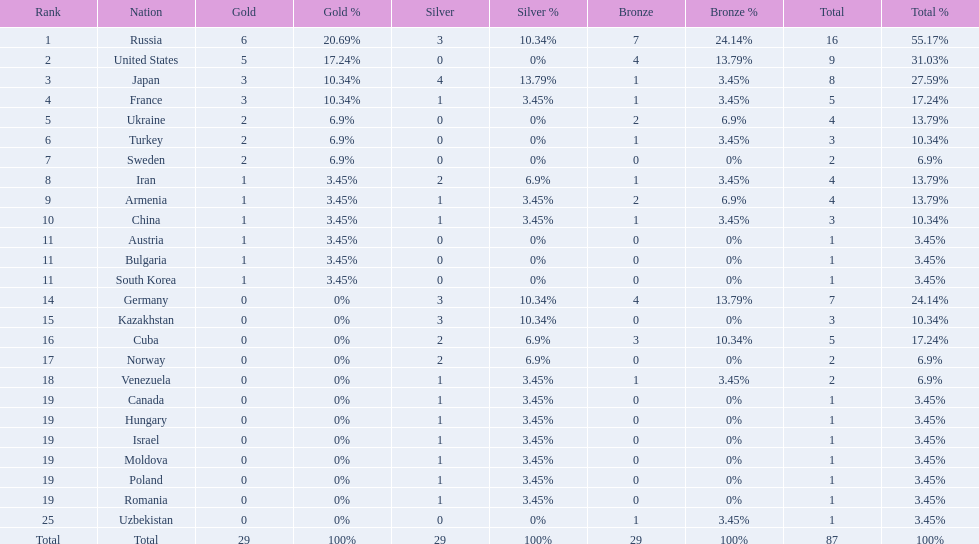Which countries competed in the 1995 world wrestling championships? Russia, United States, Japan, France, Ukraine, Turkey, Sweden, Iran, Armenia, China, Austria, Bulgaria, South Korea, Germany, Kazakhstan, Cuba, Norway, Venezuela, Canada, Hungary, Israel, Moldova, Poland, Romania, Uzbekistan. What country won only one medal? Austria, Bulgaria, South Korea, Canada, Hungary, Israel, Moldova, Poland, Romania, Uzbekistan. Which of these won a bronze medal? Uzbekistan. 